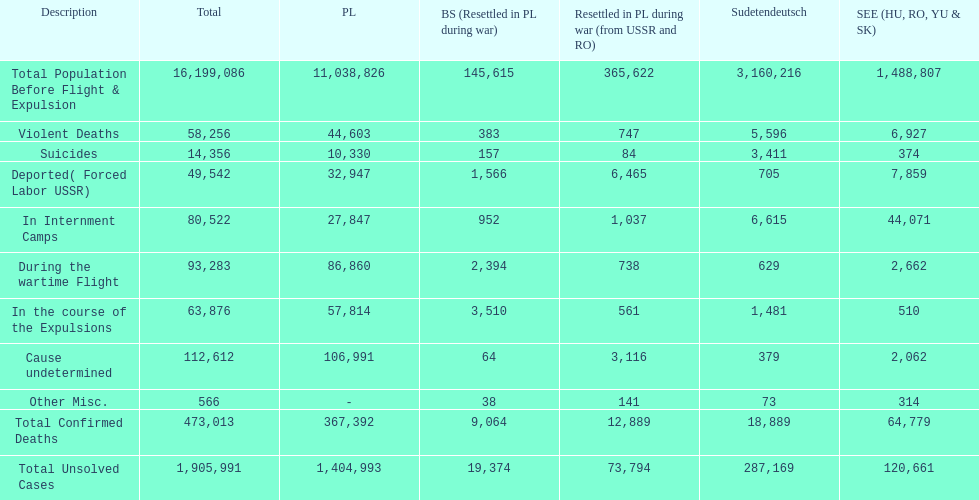In which nation was the death toll higher? Poland. 